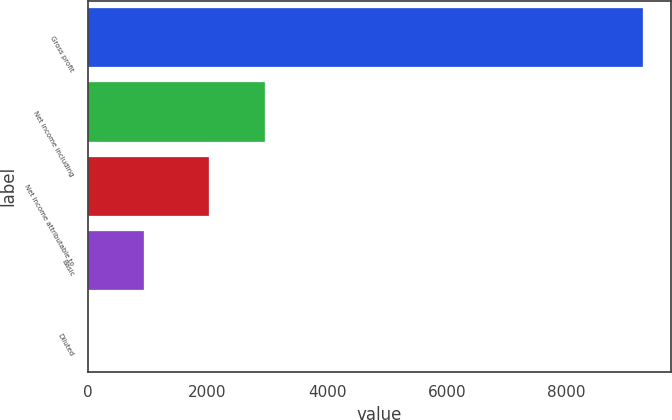<chart> <loc_0><loc_0><loc_500><loc_500><bar_chart><fcel>Gross profit<fcel>Net income including<fcel>Net income attributable to<fcel>Basic<fcel>Diluted<nl><fcel>9280<fcel>2951.77<fcel>2024<fcel>930.05<fcel>2.28<nl></chart> 